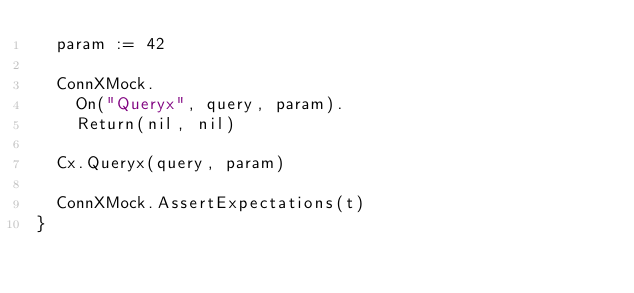<code> <loc_0><loc_0><loc_500><loc_500><_Go_>	param := 42

	ConnXMock.
		On("Queryx", query, param).
		Return(nil, nil)

	Cx.Queryx(query, param)

	ConnXMock.AssertExpectations(t)
}
</code> 